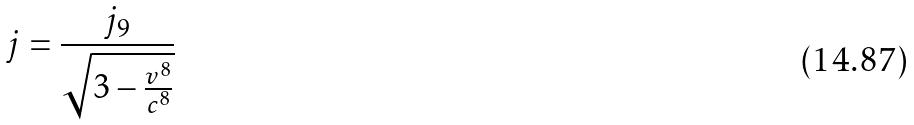<formula> <loc_0><loc_0><loc_500><loc_500>j = \frac { j _ { 9 } } { \sqrt { 3 - \frac { v ^ { 8 } } { c ^ { 8 } } } }</formula> 